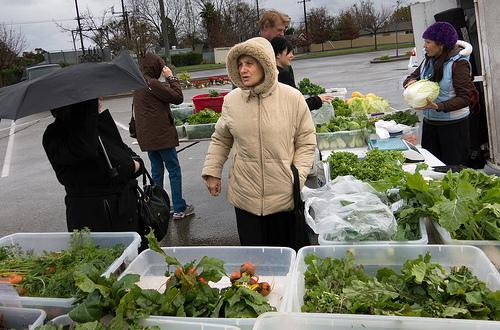Question: when are the people at the farmers market?
Choices:
A. Daytime.
B. Night.
C. Noon.
D. Mornign.
Answer with the letter. Answer: A Question: what is being sold?
Choices:
A. Fruit.
B. Puppies.
C. Kittens.
D. Vegetables.
Answer with the letter. Answer: D Question: why is an umbrella being used?
Choices:
A. Dance routine.
B. Photo.
C. Prop.
D. Rain.
Answer with the letter. Answer: D Question: what are the vegetables in?
Choices:
A. Plastic bins.
B. Bowl.
C. Plate.
D. Table.
Answer with the letter. Answer: A Question: who is wearing a purple hat?
Choices:
A. Man.
B. The vegetable seller.
C. Lady.
D. Child.
Answer with the letter. Answer: B 